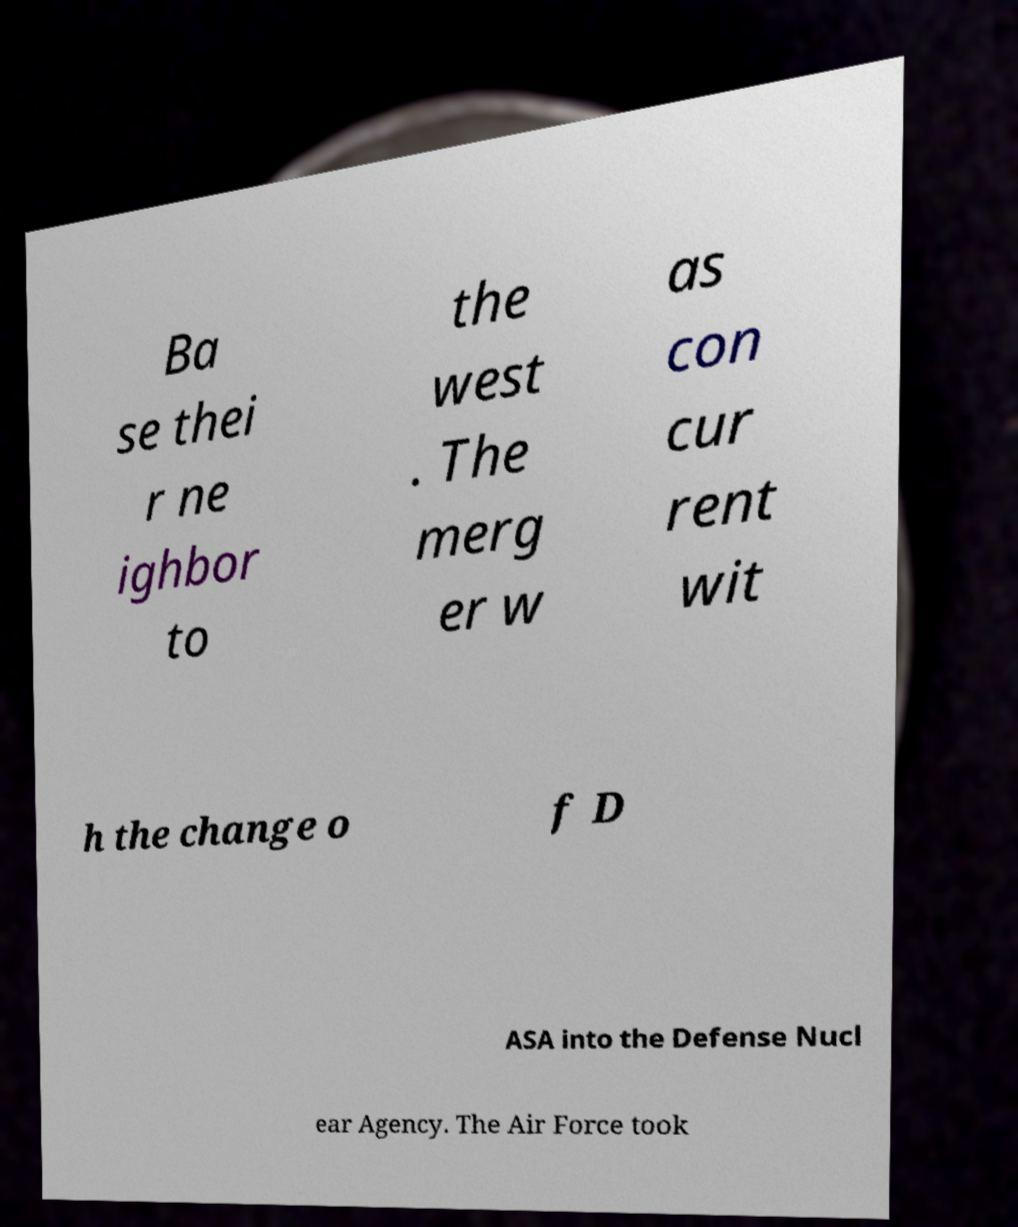There's text embedded in this image that I need extracted. Can you transcribe it verbatim? Ba se thei r ne ighbor to the west . The merg er w as con cur rent wit h the change o f D ASA into the Defense Nucl ear Agency. The Air Force took 